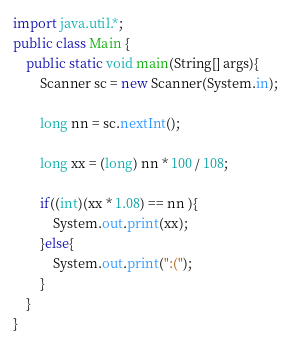Convert code to text. <code><loc_0><loc_0><loc_500><loc_500><_Java_>import java.util.*;
public class Main {
	public static void main(String[] args){
		Scanner sc = new Scanner(System.in);
		
		long nn = sc.nextInt();
		
		long xx = (long) nn * 100 / 108;
		
		if((int)(xx * 1.08) == nn ){
			System.out.print(xx);
		}else{
			System.out.print(":(");
		}
	}
}</code> 